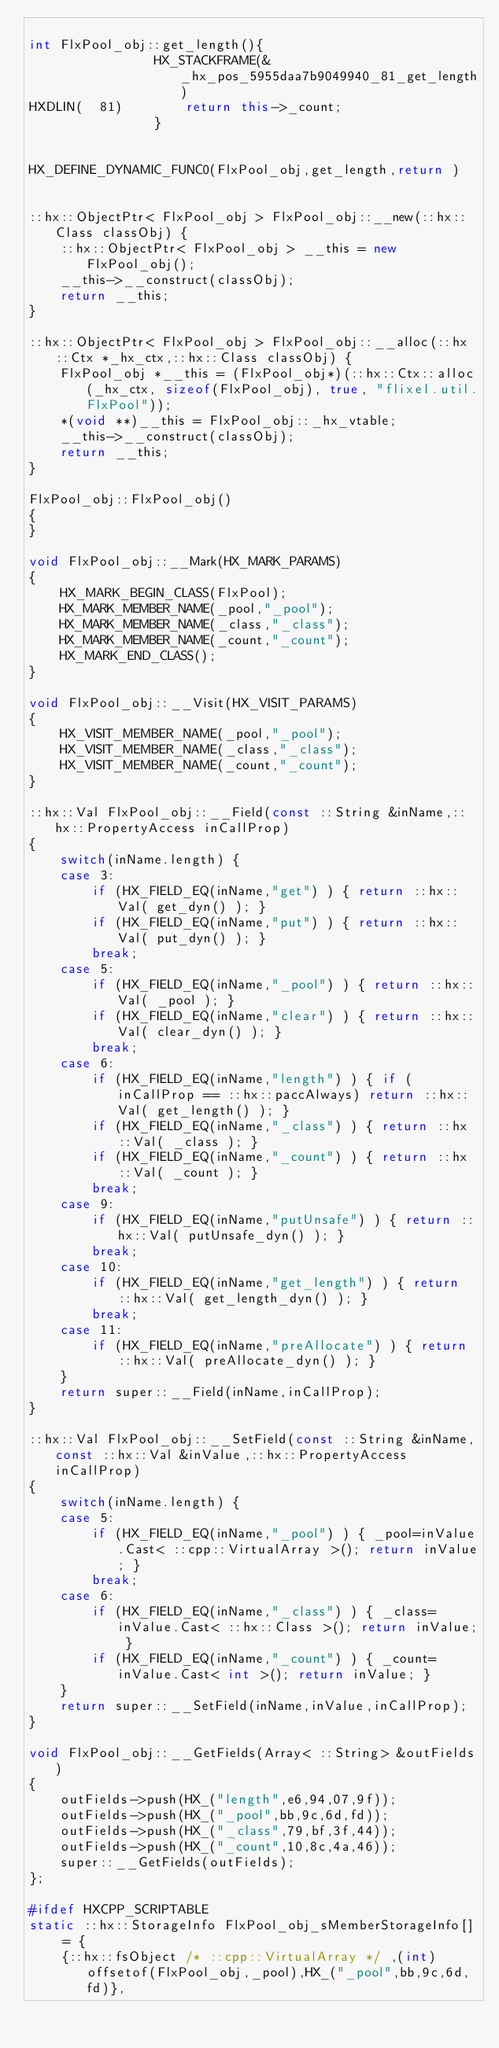<code> <loc_0><loc_0><loc_500><loc_500><_C++_>
int FlxPool_obj::get_length(){
            	HX_STACKFRAME(&_hx_pos_5955daa7b9049940_81_get_length)
HXDLIN(  81)		return this->_count;
            	}


HX_DEFINE_DYNAMIC_FUNC0(FlxPool_obj,get_length,return )


::hx::ObjectPtr< FlxPool_obj > FlxPool_obj::__new(::hx::Class classObj) {
	::hx::ObjectPtr< FlxPool_obj > __this = new FlxPool_obj();
	__this->__construct(classObj);
	return __this;
}

::hx::ObjectPtr< FlxPool_obj > FlxPool_obj::__alloc(::hx::Ctx *_hx_ctx,::hx::Class classObj) {
	FlxPool_obj *__this = (FlxPool_obj*)(::hx::Ctx::alloc(_hx_ctx, sizeof(FlxPool_obj), true, "flixel.util.FlxPool"));
	*(void **)__this = FlxPool_obj::_hx_vtable;
	__this->__construct(classObj);
	return __this;
}

FlxPool_obj::FlxPool_obj()
{
}

void FlxPool_obj::__Mark(HX_MARK_PARAMS)
{
	HX_MARK_BEGIN_CLASS(FlxPool);
	HX_MARK_MEMBER_NAME(_pool,"_pool");
	HX_MARK_MEMBER_NAME(_class,"_class");
	HX_MARK_MEMBER_NAME(_count,"_count");
	HX_MARK_END_CLASS();
}

void FlxPool_obj::__Visit(HX_VISIT_PARAMS)
{
	HX_VISIT_MEMBER_NAME(_pool,"_pool");
	HX_VISIT_MEMBER_NAME(_class,"_class");
	HX_VISIT_MEMBER_NAME(_count,"_count");
}

::hx::Val FlxPool_obj::__Field(const ::String &inName,::hx::PropertyAccess inCallProp)
{
	switch(inName.length) {
	case 3:
		if (HX_FIELD_EQ(inName,"get") ) { return ::hx::Val( get_dyn() ); }
		if (HX_FIELD_EQ(inName,"put") ) { return ::hx::Val( put_dyn() ); }
		break;
	case 5:
		if (HX_FIELD_EQ(inName,"_pool") ) { return ::hx::Val( _pool ); }
		if (HX_FIELD_EQ(inName,"clear") ) { return ::hx::Val( clear_dyn() ); }
		break;
	case 6:
		if (HX_FIELD_EQ(inName,"length") ) { if (inCallProp == ::hx::paccAlways) return ::hx::Val( get_length() ); }
		if (HX_FIELD_EQ(inName,"_class") ) { return ::hx::Val( _class ); }
		if (HX_FIELD_EQ(inName,"_count") ) { return ::hx::Val( _count ); }
		break;
	case 9:
		if (HX_FIELD_EQ(inName,"putUnsafe") ) { return ::hx::Val( putUnsafe_dyn() ); }
		break;
	case 10:
		if (HX_FIELD_EQ(inName,"get_length") ) { return ::hx::Val( get_length_dyn() ); }
		break;
	case 11:
		if (HX_FIELD_EQ(inName,"preAllocate") ) { return ::hx::Val( preAllocate_dyn() ); }
	}
	return super::__Field(inName,inCallProp);
}

::hx::Val FlxPool_obj::__SetField(const ::String &inName,const ::hx::Val &inValue,::hx::PropertyAccess inCallProp)
{
	switch(inName.length) {
	case 5:
		if (HX_FIELD_EQ(inName,"_pool") ) { _pool=inValue.Cast< ::cpp::VirtualArray >(); return inValue; }
		break;
	case 6:
		if (HX_FIELD_EQ(inName,"_class") ) { _class=inValue.Cast< ::hx::Class >(); return inValue; }
		if (HX_FIELD_EQ(inName,"_count") ) { _count=inValue.Cast< int >(); return inValue; }
	}
	return super::__SetField(inName,inValue,inCallProp);
}

void FlxPool_obj::__GetFields(Array< ::String> &outFields)
{
	outFields->push(HX_("length",e6,94,07,9f));
	outFields->push(HX_("_pool",bb,9c,6d,fd));
	outFields->push(HX_("_class",79,bf,3f,44));
	outFields->push(HX_("_count",10,8c,4a,46));
	super::__GetFields(outFields);
};

#ifdef HXCPP_SCRIPTABLE
static ::hx::StorageInfo FlxPool_obj_sMemberStorageInfo[] = {
	{::hx::fsObject /* ::cpp::VirtualArray */ ,(int)offsetof(FlxPool_obj,_pool),HX_("_pool",bb,9c,6d,fd)},</code> 